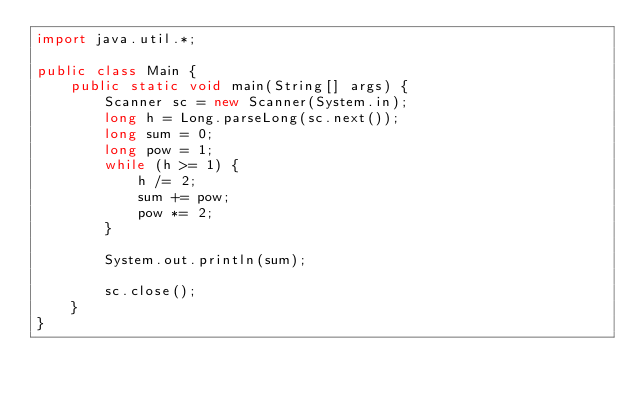Convert code to text. <code><loc_0><loc_0><loc_500><loc_500><_Java_>import java.util.*;

public class Main {
	public static void main(String[] args) {
		Scanner sc = new Scanner(System.in);
		long h = Long.parseLong(sc.next());
		long sum = 0;
		long pow = 1;
		while (h >= 1) {
			h /= 2;
			sum += pow;
			pow *= 2;
		}

		System.out.println(sum);

		sc.close();
	}
}</code> 